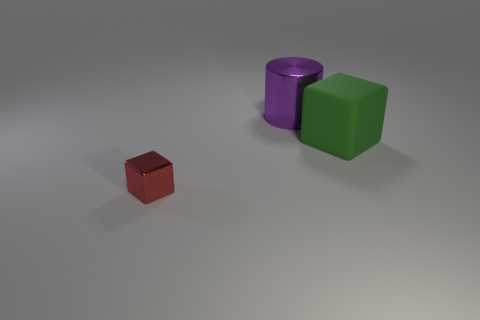Is there anything else that has the same size as the red metallic cube?
Provide a succinct answer. No. What number of other purple shiny things are the same shape as the big purple object?
Give a very brief answer. 0. Is there any other thing that has the same shape as the small red thing?
Provide a succinct answer. Yes. Is the thing to the left of the shiny cylinder made of the same material as the object that is behind the matte thing?
Offer a terse response. Yes. What is the color of the big cylinder?
Offer a very short reply. Purple. What is the size of the metal thing in front of the metallic thing behind the object in front of the large rubber cube?
Your response must be concise. Small. How many other things are there of the same size as the purple object?
Offer a terse response. 1. What number of tiny red cubes have the same material as the big purple object?
Your answer should be compact. 1. There is a large object right of the large cylinder; what shape is it?
Your response must be concise. Cube. Are the large green object and the big object that is left of the green cube made of the same material?
Your answer should be very brief. No. 